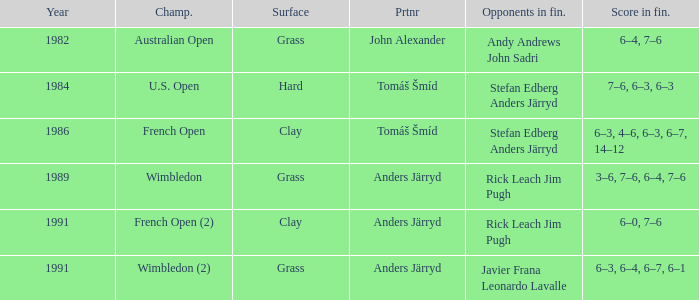Who was his partner in 1989?  Anders Järryd. 